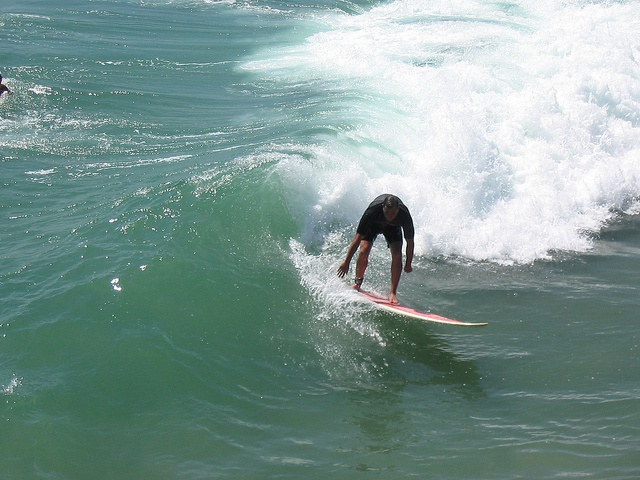Describe the objects in this image and their specific colors. I can see people in gray, black, maroon, and darkgray tones and surfboard in gray, lightpink, lightgray, and darkgray tones in this image. 